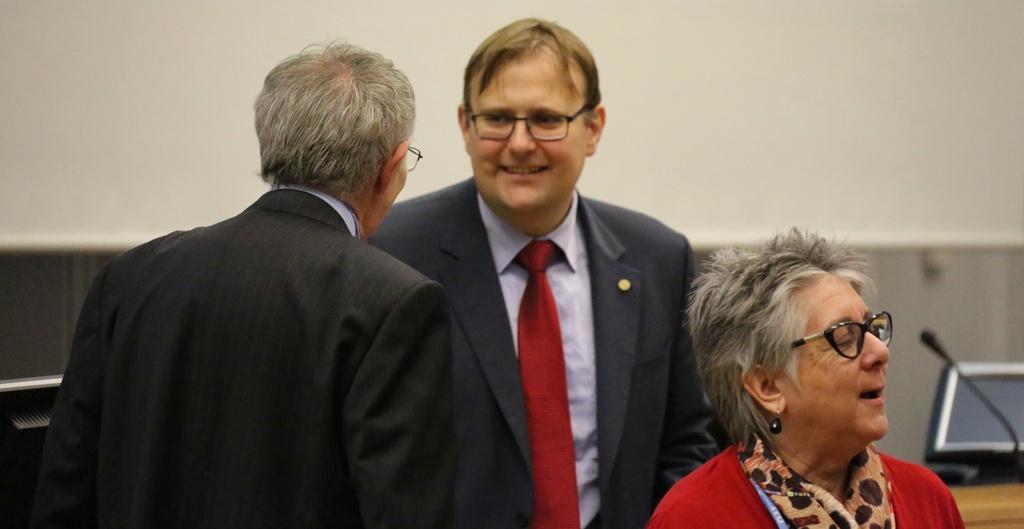Describe this image in one or two sentences. In this picture we can see there are three people on the path and behind the people there are monitors, microphone and a wall. 